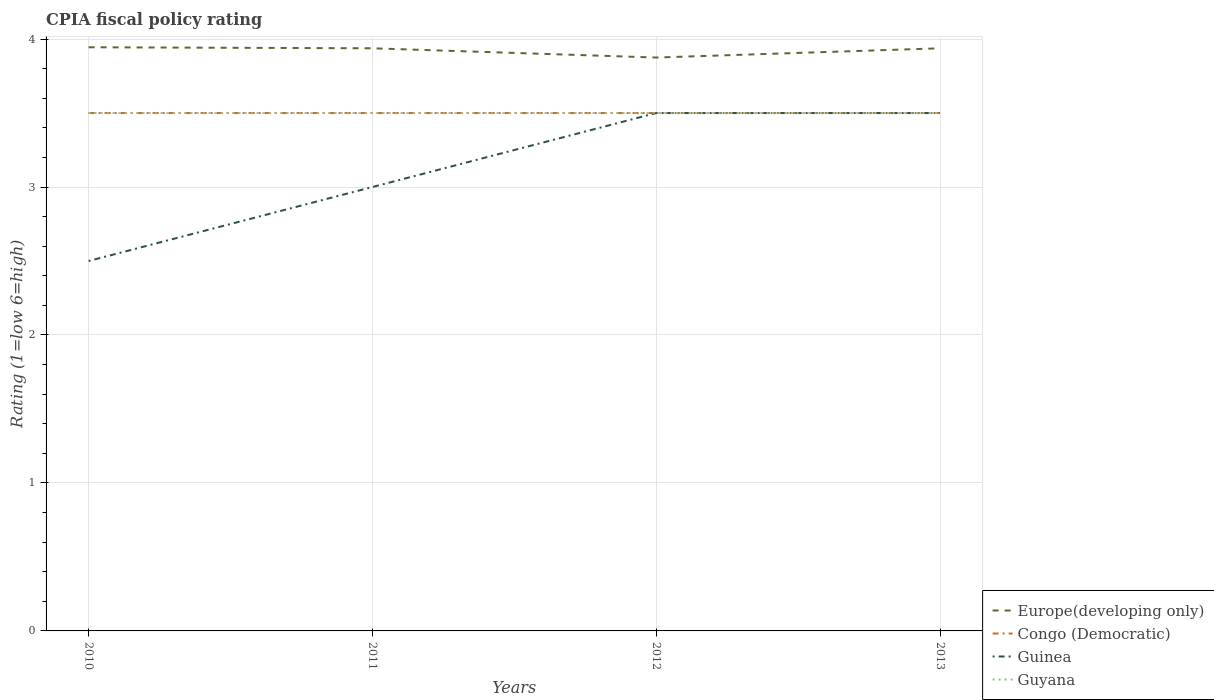How many different coloured lines are there?
Offer a terse response. 4. Does the line corresponding to Guyana intersect with the line corresponding to Congo (Democratic)?
Keep it short and to the point. Yes. Across all years, what is the maximum CPIA rating in Congo (Democratic)?
Ensure brevity in your answer.  3.5. In which year was the CPIA rating in Guinea maximum?
Offer a very short reply. 2010. What is the total CPIA rating in Europe(developing only) in the graph?
Make the answer very short. -0.06. What is the difference between the highest and the second highest CPIA rating in Guinea?
Offer a very short reply. 1. Is the CPIA rating in Guyana strictly greater than the CPIA rating in Europe(developing only) over the years?
Give a very brief answer. Yes. Are the values on the major ticks of Y-axis written in scientific E-notation?
Give a very brief answer. No. How are the legend labels stacked?
Give a very brief answer. Vertical. What is the title of the graph?
Keep it short and to the point. CPIA fiscal policy rating. Does "Gambia, The" appear as one of the legend labels in the graph?
Keep it short and to the point. No. What is the label or title of the Y-axis?
Ensure brevity in your answer.  Rating (1=low 6=high). What is the Rating (1=low 6=high) in Europe(developing only) in 2010?
Offer a very short reply. 3.94. What is the Rating (1=low 6=high) in Guyana in 2010?
Give a very brief answer. 3.5. What is the Rating (1=low 6=high) in Europe(developing only) in 2011?
Provide a short and direct response. 3.94. What is the Rating (1=low 6=high) of Guinea in 2011?
Keep it short and to the point. 3. What is the Rating (1=low 6=high) of Europe(developing only) in 2012?
Ensure brevity in your answer.  3.88. What is the Rating (1=low 6=high) in Congo (Democratic) in 2012?
Provide a short and direct response. 3.5. What is the Rating (1=low 6=high) in Europe(developing only) in 2013?
Offer a very short reply. 3.94. What is the Rating (1=low 6=high) in Guinea in 2013?
Make the answer very short. 3.5. Across all years, what is the maximum Rating (1=low 6=high) in Europe(developing only)?
Offer a very short reply. 3.94. Across all years, what is the maximum Rating (1=low 6=high) of Congo (Democratic)?
Your answer should be very brief. 3.5. Across all years, what is the maximum Rating (1=low 6=high) of Guinea?
Give a very brief answer. 3.5. Across all years, what is the minimum Rating (1=low 6=high) of Europe(developing only)?
Keep it short and to the point. 3.88. Across all years, what is the minimum Rating (1=low 6=high) of Congo (Democratic)?
Ensure brevity in your answer.  3.5. What is the total Rating (1=low 6=high) of Europe(developing only) in the graph?
Provide a short and direct response. 15.69. What is the total Rating (1=low 6=high) in Congo (Democratic) in the graph?
Make the answer very short. 14. What is the difference between the Rating (1=low 6=high) in Europe(developing only) in 2010 and that in 2011?
Offer a terse response. 0.01. What is the difference between the Rating (1=low 6=high) in Guinea in 2010 and that in 2011?
Provide a short and direct response. -0.5. What is the difference between the Rating (1=low 6=high) in Guyana in 2010 and that in 2011?
Provide a short and direct response. 0. What is the difference between the Rating (1=low 6=high) in Europe(developing only) in 2010 and that in 2012?
Ensure brevity in your answer.  0.07. What is the difference between the Rating (1=low 6=high) of Congo (Democratic) in 2010 and that in 2012?
Keep it short and to the point. 0. What is the difference between the Rating (1=low 6=high) in Guinea in 2010 and that in 2012?
Ensure brevity in your answer.  -1. What is the difference between the Rating (1=low 6=high) in Guyana in 2010 and that in 2012?
Provide a short and direct response. 0. What is the difference between the Rating (1=low 6=high) of Europe(developing only) in 2010 and that in 2013?
Offer a very short reply. 0.01. What is the difference between the Rating (1=low 6=high) of Congo (Democratic) in 2010 and that in 2013?
Keep it short and to the point. 0. What is the difference between the Rating (1=low 6=high) of Guinea in 2010 and that in 2013?
Keep it short and to the point. -1. What is the difference between the Rating (1=low 6=high) of Europe(developing only) in 2011 and that in 2012?
Make the answer very short. 0.06. What is the difference between the Rating (1=low 6=high) in Congo (Democratic) in 2011 and that in 2012?
Provide a short and direct response. 0. What is the difference between the Rating (1=low 6=high) of Guinea in 2011 and that in 2012?
Your answer should be compact. -0.5. What is the difference between the Rating (1=low 6=high) in Guyana in 2011 and that in 2012?
Keep it short and to the point. 0. What is the difference between the Rating (1=low 6=high) of Europe(developing only) in 2011 and that in 2013?
Provide a short and direct response. 0. What is the difference between the Rating (1=low 6=high) in Europe(developing only) in 2012 and that in 2013?
Make the answer very short. -0.06. What is the difference between the Rating (1=low 6=high) in Europe(developing only) in 2010 and the Rating (1=low 6=high) in Congo (Democratic) in 2011?
Provide a succinct answer. 0.44. What is the difference between the Rating (1=low 6=high) in Europe(developing only) in 2010 and the Rating (1=low 6=high) in Guyana in 2011?
Keep it short and to the point. 0.44. What is the difference between the Rating (1=low 6=high) of Congo (Democratic) in 2010 and the Rating (1=low 6=high) of Guinea in 2011?
Provide a short and direct response. 0.5. What is the difference between the Rating (1=low 6=high) in Congo (Democratic) in 2010 and the Rating (1=low 6=high) in Guyana in 2011?
Ensure brevity in your answer.  0. What is the difference between the Rating (1=low 6=high) in Europe(developing only) in 2010 and the Rating (1=low 6=high) in Congo (Democratic) in 2012?
Your response must be concise. 0.44. What is the difference between the Rating (1=low 6=high) in Europe(developing only) in 2010 and the Rating (1=low 6=high) in Guinea in 2012?
Provide a short and direct response. 0.44. What is the difference between the Rating (1=low 6=high) of Europe(developing only) in 2010 and the Rating (1=low 6=high) of Guyana in 2012?
Your response must be concise. 0.44. What is the difference between the Rating (1=low 6=high) in Congo (Democratic) in 2010 and the Rating (1=low 6=high) in Guinea in 2012?
Ensure brevity in your answer.  0. What is the difference between the Rating (1=low 6=high) of Congo (Democratic) in 2010 and the Rating (1=low 6=high) of Guyana in 2012?
Your response must be concise. 0. What is the difference between the Rating (1=low 6=high) of Europe(developing only) in 2010 and the Rating (1=low 6=high) of Congo (Democratic) in 2013?
Offer a terse response. 0.44. What is the difference between the Rating (1=low 6=high) of Europe(developing only) in 2010 and the Rating (1=low 6=high) of Guinea in 2013?
Ensure brevity in your answer.  0.44. What is the difference between the Rating (1=low 6=high) in Europe(developing only) in 2010 and the Rating (1=low 6=high) in Guyana in 2013?
Provide a succinct answer. 0.44. What is the difference between the Rating (1=low 6=high) in Guinea in 2010 and the Rating (1=low 6=high) in Guyana in 2013?
Your response must be concise. -1. What is the difference between the Rating (1=low 6=high) of Europe(developing only) in 2011 and the Rating (1=low 6=high) of Congo (Democratic) in 2012?
Ensure brevity in your answer.  0.44. What is the difference between the Rating (1=low 6=high) of Europe(developing only) in 2011 and the Rating (1=low 6=high) of Guinea in 2012?
Make the answer very short. 0.44. What is the difference between the Rating (1=low 6=high) of Europe(developing only) in 2011 and the Rating (1=low 6=high) of Guyana in 2012?
Offer a very short reply. 0.44. What is the difference between the Rating (1=low 6=high) of Congo (Democratic) in 2011 and the Rating (1=low 6=high) of Guinea in 2012?
Provide a succinct answer. 0. What is the difference between the Rating (1=low 6=high) in Congo (Democratic) in 2011 and the Rating (1=low 6=high) in Guyana in 2012?
Provide a short and direct response. 0. What is the difference between the Rating (1=low 6=high) in Europe(developing only) in 2011 and the Rating (1=low 6=high) in Congo (Democratic) in 2013?
Provide a succinct answer. 0.44. What is the difference between the Rating (1=low 6=high) of Europe(developing only) in 2011 and the Rating (1=low 6=high) of Guinea in 2013?
Make the answer very short. 0.44. What is the difference between the Rating (1=low 6=high) of Europe(developing only) in 2011 and the Rating (1=low 6=high) of Guyana in 2013?
Keep it short and to the point. 0.44. What is the difference between the Rating (1=low 6=high) in Congo (Democratic) in 2011 and the Rating (1=low 6=high) in Guyana in 2013?
Provide a succinct answer. 0. What is the difference between the Rating (1=low 6=high) of Europe(developing only) in 2012 and the Rating (1=low 6=high) of Congo (Democratic) in 2013?
Make the answer very short. 0.38. What is the difference between the Rating (1=low 6=high) of Europe(developing only) in 2012 and the Rating (1=low 6=high) of Guinea in 2013?
Your answer should be very brief. 0.38. What is the difference between the Rating (1=low 6=high) in Congo (Democratic) in 2012 and the Rating (1=low 6=high) in Guyana in 2013?
Offer a very short reply. 0. What is the difference between the Rating (1=low 6=high) in Guinea in 2012 and the Rating (1=low 6=high) in Guyana in 2013?
Your answer should be very brief. 0. What is the average Rating (1=low 6=high) in Europe(developing only) per year?
Your answer should be very brief. 3.92. What is the average Rating (1=low 6=high) of Guinea per year?
Offer a terse response. 3.12. What is the average Rating (1=low 6=high) in Guyana per year?
Your response must be concise. 3.5. In the year 2010, what is the difference between the Rating (1=low 6=high) in Europe(developing only) and Rating (1=low 6=high) in Congo (Democratic)?
Offer a very short reply. 0.44. In the year 2010, what is the difference between the Rating (1=low 6=high) in Europe(developing only) and Rating (1=low 6=high) in Guinea?
Make the answer very short. 1.44. In the year 2010, what is the difference between the Rating (1=low 6=high) of Europe(developing only) and Rating (1=low 6=high) of Guyana?
Ensure brevity in your answer.  0.44. In the year 2010, what is the difference between the Rating (1=low 6=high) in Congo (Democratic) and Rating (1=low 6=high) in Guyana?
Give a very brief answer. 0. In the year 2011, what is the difference between the Rating (1=low 6=high) in Europe(developing only) and Rating (1=low 6=high) in Congo (Democratic)?
Provide a short and direct response. 0.44. In the year 2011, what is the difference between the Rating (1=low 6=high) in Europe(developing only) and Rating (1=low 6=high) in Guinea?
Make the answer very short. 0.94. In the year 2011, what is the difference between the Rating (1=low 6=high) of Europe(developing only) and Rating (1=low 6=high) of Guyana?
Provide a short and direct response. 0.44. In the year 2011, what is the difference between the Rating (1=low 6=high) of Congo (Democratic) and Rating (1=low 6=high) of Guinea?
Offer a very short reply. 0.5. In the year 2011, what is the difference between the Rating (1=low 6=high) of Guinea and Rating (1=low 6=high) of Guyana?
Provide a succinct answer. -0.5. In the year 2012, what is the difference between the Rating (1=low 6=high) in Congo (Democratic) and Rating (1=low 6=high) in Guinea?
Your response must be concise. 0. In the year 2012, what is the difference between the Rating (1=low 6=high) of Congo (Democratic) and Rating (1=low 6=high) of Guyana?
Your answer should be very brief. 0. In the year 2012, what is the difference between the Rating (1=low 6=high) of Guinea and Rating (1=low 6=high) of Guyana?
Offer a very short reply. 0. In the year 2013, what is the difference between the Rating (1=low 6=high) in Europe(developing only) and Rating (1=low 6=high) in Congo (Democratic)?
Your answer should be very brief. 0.44. In the year 2013, what is the difference between the Rating (1=low 6=high) of Europe(developing only) and Rating (1=low 6=high) of Guinea?
Your answer should be compact. 0.44. In the year 2013, what is the difference between the Rating (1=low 6=high) in Europe(developing only) and Rating (1=low 6=high) in Guyana?
Offer a very short reply. 0.44. In the year 2013, what is the difference between the Rating (1=low 6=high) in Congo (Democratic) and Rating (1=low 6=high) in Guyana?
Your answer should be very brief. 0. In the year 2013, what is the difference between the Rating (1=low 6=high) of Guinea and Rating (1=low 6=high) of Guyana?
Ensure brevity in your answer.  0. What is the ratio of the Rating (1=low 6=high) in Europe(developing only) in 2010 to that in 2011?
Your answer should be compact. 1. What is the ratio of the Rating (1=low 6=high) of Europe(developing only) in 2010 to that in 2012?
Ensure brevity in your answer.  1.02. What is the ratio of the Rating (1=low 6=high) of Congo (Democratic) in 2010 to that in 2012?
Offer a very short reply. 1. What is the ratio of the Rating (1=low 6=high) of Guyana in 2010 to that in 2012?
Offer a terse response. 1. What is the ratio of the Rating (1=low 6=high) in Congo (Democratic) in 2010 to that in 2013?
Ensure brevity in your answer.  1. What is the ratio of the Rating (1=low 6=high) of Guyana in 2010 to that in 2013?
Your answer should be very brief. 1. What is the ratio of the Rating (1=low 6=high) of Europe(developing only) in 2011 to that in 2012?
Ensure brevity in your answer.  1.02. What is the ratio of the Rating (1=low 6=high) of Congo (Democratic) in 2011 to that in 2012?
Keep it short and to the point. 1. What is the ratio of the Rating (1=low 6=high) in Europe(developing only) in 2011 to that in 2013?
Make the answer very short. 1. What is the ratio of the Rating (1=low 6=high) in Europe(developing only) in 2012 to that in 2013?
Provide a succinct answer. 0.98. What is the ratio of the Rating (1=low 6=high) of Guinea in 2012 to that in 2013?
Your response must be concise. 1. What is the ratio of the Rating (1=low 6=high) in Guyana in 2012 to that in 2013?
Keep it short and to the point. 1. What is the difference between the highest and the second highest Rating (1=low 6=high) in Europe(developing only)?
Your response must be concise. 0.01. What is the difference between the highest and the second highest Rating (1=low 6=high) of Guinea?
Make the answer very short. 0. What is the difference between the highest and the lowest Rating (1=low 6=high) of Europe(developing only)?
Give a very brief answer. 0.07. What is the difference between the highest and the lowest Rating (1=low 6=high) of Congo (Democratic)?
Make the answer very short. 0. What is the difference between the highest and the lowest Rating (1=low 6=high) in Guinea?
Keep it short and to the point. 1. What is the difference between the highest and the lowest Rating (1=low 6=high) of Guyana?
Offer a very short reply. 0. 